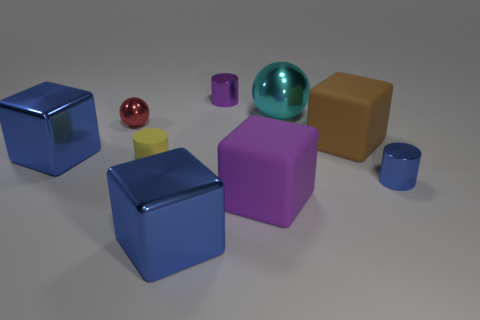Subtract all purple matte cubes. How many cubes are left? 3 Subtract 1 cylinders. How many cylinders are left? 2 Subtract all brown cubes. How many cubes are left? 3 Subtract 1 blue cylinders. How many objects are left? 8 Subtract all blocks. How many objects are left? 5 Subtract all brown cubes. Subtract all gray spheres. How many cubes are left? 3 Subtract all green cylinders. How many brown blocks are left? 1 Subtract all small cyan rubber spheres. Subtract all small blue shiny cylinders. How many objects are left? 8 Add 2 cubes. How many cubes are left? 6 Add 4 blue metallic cylinders. How many blue metallic cylinders exist? 5 